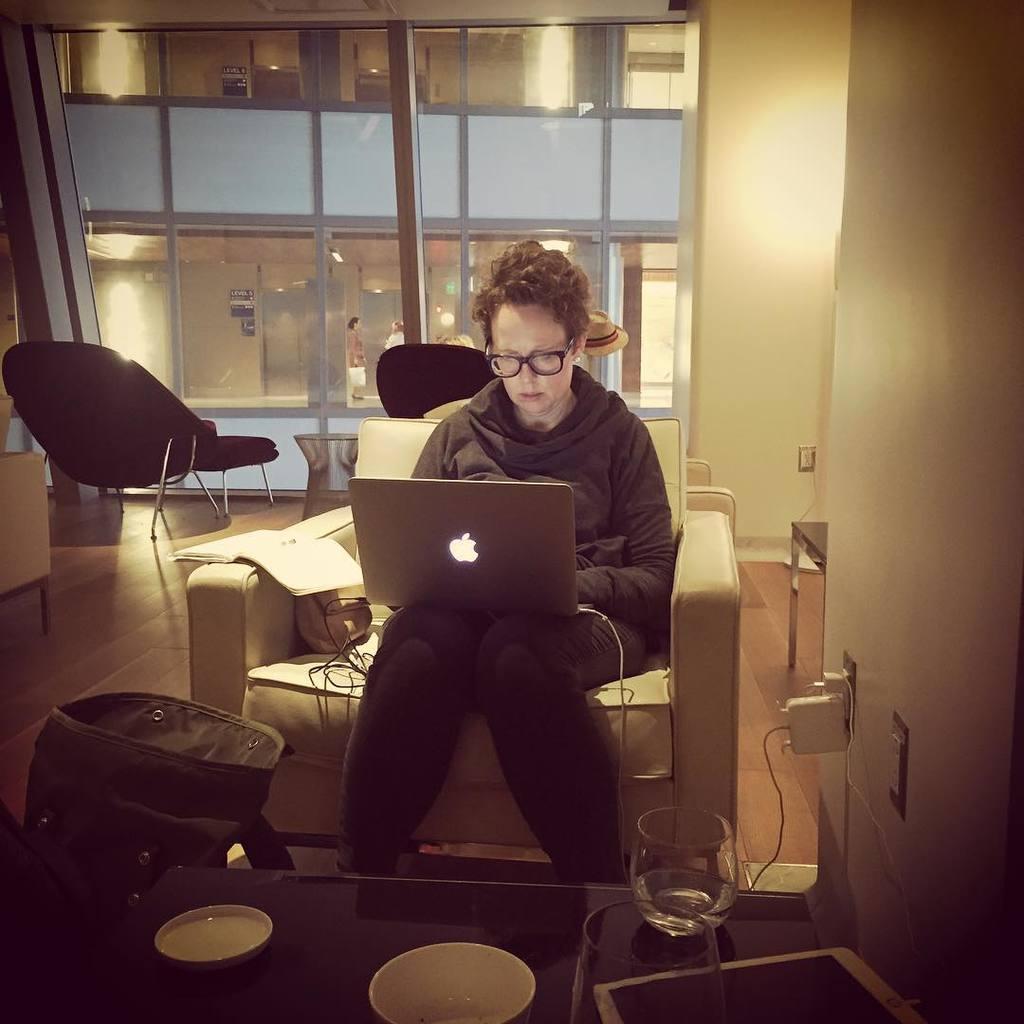In one or two sentences, can you explain what this image depicts? In this picture we can see couple of glasses, bowls and a tablet on the table, and also we can find a woman she is seated on the sofa and she is working with laptop, in front of her we can find bag and we can see a book on the sofa, in the background we can see a chair, couple of lights and two persons. 